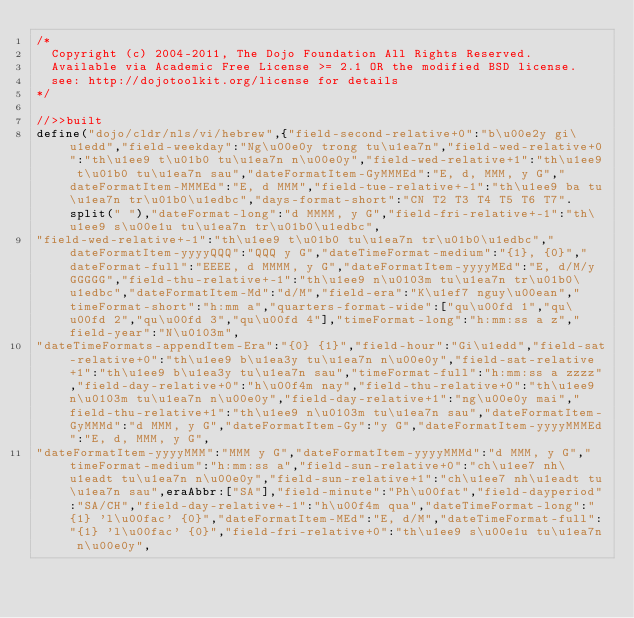Convert code to text. <code><loc_0><loc_0><loc_500><loc_500><_JavaScript_>/*
	Copyright (c) 2004-2011, The Dojo Foundation All Rights Reserved.
	Available via Academic Free License >= 2.1 OR the modified BSD license.
	see: http://dojotoolkit.org/license for details
*/

//>>built
define("dojo/cldr/nls/vi/hebrew",{"field-second-relative+0":"b\u00e2y gi\u1edd","field-weekday":"Ng\u00e0y trong tu\u1ea7n","field-wed-relative+0":"th\u1ee9 t\u01b0 tu\u1ea7n n\u00e0y","field-wed-relative+1":"th\u1ee9 t\u01b0 tu\u1ea7n sau","dateFormatItem-GyMMMEd":"E, d, MMM, y G","dateFormatItem-MMMEd":"E, d MMM","field-tue-relative+-1":"th\u1ee9 ba tu\u1ea7n tr\u01b0\u1edbc","days-format-short":"CN T2 T3 T4 T5 T6 T7".split(" "),"dateFormat-long":"d MMMM, y G","field-fri-relative+-1":"th\u1ee9 s\u00e1u tu\u1ea7n tr\u01b0\u1edbc",
"field-wed-relative+-1":"th\u1ee9 t\u01b0 tu\u1ea7n tr\u01b0\u1edbc","dateFormatItem-yyyyQQQ":"QQQ y G","dateTimeFormat-medium":"{1}, {0}","dateFormat-full":"EEEE, d MMMM, y G","dateFormatItem-yyyyMEd":"E, d/M/y GGGGG","field-thu-relative+-1":"th\u1ee9 n\u0103m tu\u1ea7n tr\u01b0\u1edbc","dateFormatItem-Md":"d/M","field-era":"K\u1ef7 nguy\u00ean","timeFormat-short":"h:mm a","quarters-format-wide":["qu\u00fd 1","qu\u00fd 2","qu\u00fd 3","qu\u00fd 4"],"timeFormat-long":"h:mm:ss a z","field-year":"N\u0103m",
"dateTimeFormats-appendItem-Era":"{0} {1}","field-hour":"Gi\u1edd","field-sat-relative+0":"th\u1ee9 b\u1ea3y tu\u1ea7n n\u00e0y","field-sat-relative+1":"th\u1ee9 b\u1ea3y tu\u1ea7n sau","timeFormat-full":"h:mm:ss a zzzz","field-day-relative+0":"h\u00f4m nay","field-thu-relative+0":"th\u1ee9 n\u0103m tu\u1ea7n n\u00e0y","field-day-relative+1":"ng\u00e0y mai","field-thu-relative+1":"th\u1ee9 n\u0103m tu\u1ea7n sau","dateFormatItem-GyMMMd":"d MMM, y G","dateFormatItem-Gy":"y G","dateFormatItem-yyyyMMMEd":"E, d, MMM, y G",
"dateFormatItem-yyyyMMM":"MMM y G","dateFormatItem-yyyyMMMd":"d MMM, y G","timeFormat-medium":"h:mm:ss a","field-sun-relative+0":"ch\u1ee7 nh\u1eadt tu\u1ea7n n\u00e0y","field-sun-relative+1":"ch\u1ee7 nh\u1eadt tu\u1ea7n sau",eraAbbr:["SA"],"field-minute":"Ph\u00fat","field-dayperiod":"SA/CH","field-day-relative+-1":"h\u00f4m qua","dateTimeFormat-long":"{1} 'l\u00fac' {0}","dateFormatItem-MEd":"E, d/M","dateTimeFormat-full":"{1} 'l\u00fac' {0}","field-fri-relative+0":"th\u1ee9 s\u00e1u tu\u1ea7n n\u00e0y",</code> 